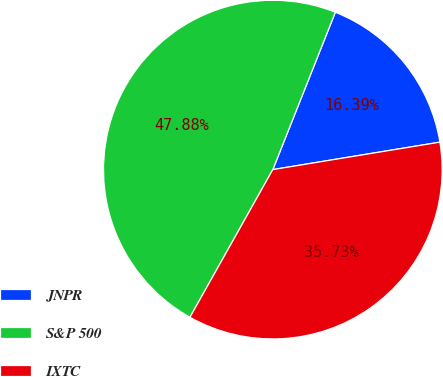Convert chart. <chart><loc_0><loc_0><loc_500><loc_500><pie_chart><fcel>JNPR<fcel>S&P 500<fcel>IXTC<nl><fcel>16.39%<fcel>47.88%<fcel>35.73%<nl></chart> 